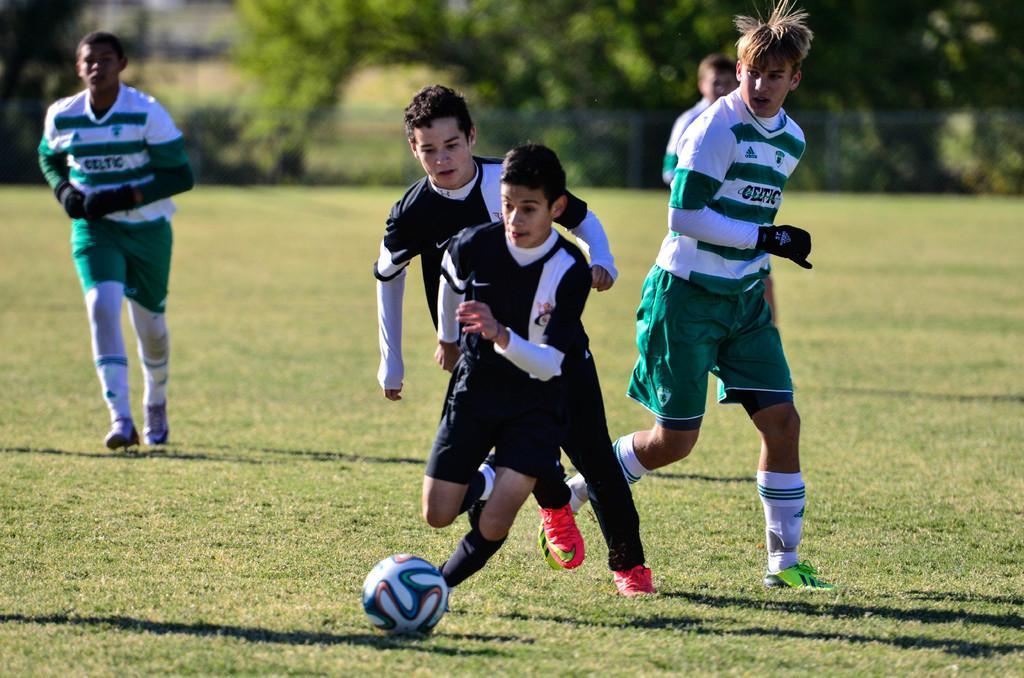Can you describe this image briefly? This is a picture taken in the outdoors. It is sunny. There are group of people playing the football on the ground. The boy in black t shirt was running to kick the ball. Behind the people there are trees. 